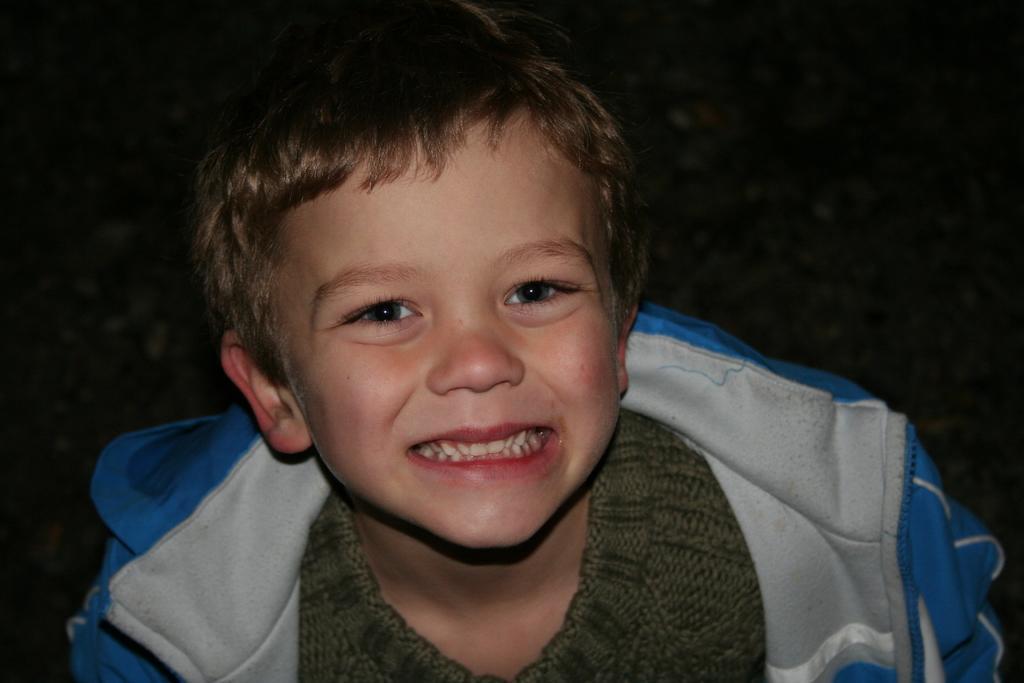In one or two sentences, can you explain what this image depicts? In this picture, we see the boy is wearing the green T-shirt and the blue jacket. He is smiling. In the background, it is black in color. This picture might be clicked in the dark. 